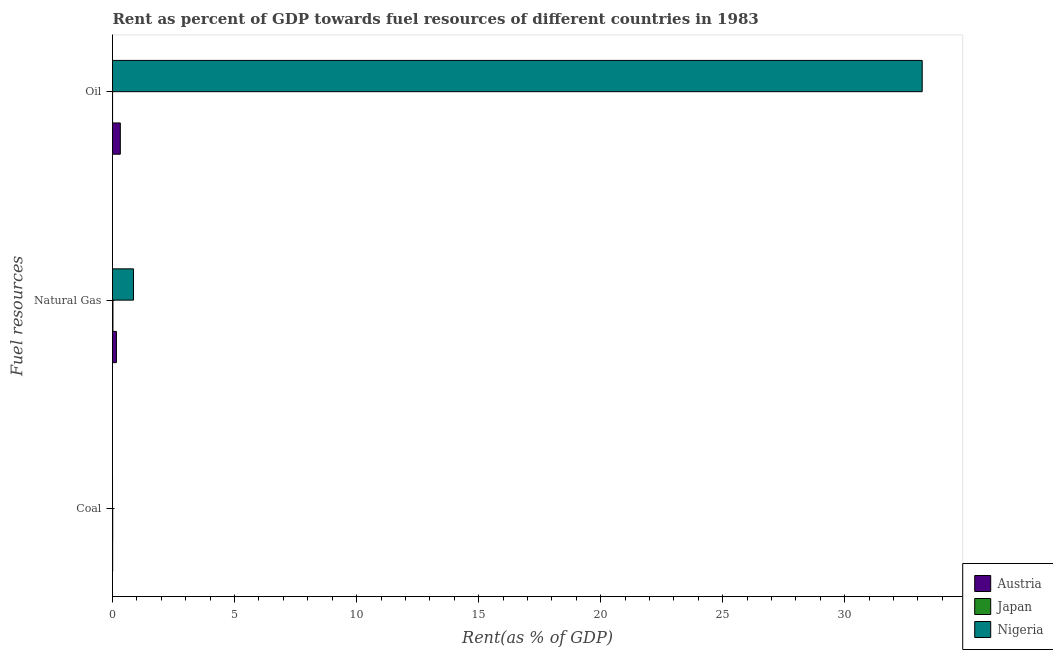How many different coloured bars are there?
Provide a succinct answer. 3. How many groups of bars are there?
Offer a terse response. 3. Are the number of bars per tick equal to the number of legend labels?
Offer a terse response. Yes. How many bars are there on the 1st tick from the top?
Your answer should be very brief. 3. What is the label of the 3rd group of bars from the top?
Keep it short and to the point. Coal. What is the rent towards natural gas in Austria?
Provide a succinct answer. 0.16. Across all countries, what is the maximum rent towards oil?
Your answer should be compact. 33.17. Across all countries, what is the minimum rent towards natural gas?
Provide a succinct answer. 0.02. In which country was the rent towards natural gas maximum?
Provide a succinct answer. Nigeria. In which country was the rent towards oil minimum?
Offer a very short reply. Japan. What is the total rent towards coal in the graph?
Provide a short and direct response. 0.02. What is the difference between the rent towards natural gas in Japan and that in Nigeria?
Your answer should be compact. -0.84. What is the difference between the rent towards natural gas in Nigeria and the rent towards coal in Austria?
Make the answer very short. 0.85. What is the average rent towards coal per country?
Your answer should be compact. 0.01. What is the difference between the rent towards natural gas and rent towards oil in Nigeria?
Provide a short and direct response. -32.31. In how many countries, is the rent towards natural gas greater than 28 %?
Keep it short and to the point. 0. What is the ratio of the rent towards oil in Japan to that in Nigeria?
Offer a terse response. 9.989106129136986e-5. Is the rent towards coal in Nigeria less than that in Japan?
Make the answer very short. Yes. Is the difference between the rent towards coal in Austria and Japan greater than the difference between the rent towards natural gas in Austria and Japan?
Provide a succinct answer. No. What is the difference between the highest and the second highest rent towards natural gas?
Your response must be concise. 0.7. What is the difference between the highest and the lowest rent towards natural gas?
Provide a succinct answer. 0.84. In how many countries, is the rent towards oil greater than the average rent towards oil taken over all countries?
Offer a very short reply. 1. Is the sum of the rent towards oil in Austria and Nigeria greater than the maximum rent towards natural gas across all countries?
Your answer should be compact. Yes. What does the 3rd bar from the top in Coal represents?
Provide a short and direct response. Austria. What does the 1st bar from the bottom in Natural Gas represents?
Your answer should be compact. Austria. Is it the case that in every country, the sum of the rent towards coal and rent towards natural gas is greater than the rent towards oil?
Your answer should be compact. No. Are all the bars in the graph horizontal?
Provide a short and direct response. Yes. How many countries are there in the graph?
Offer a very short reply. 3. Are the values on the major ticks of X-axis written in scientific E-notation?
Your answer should be compact. No. Does the graph contain any zero values?
Your response must be concise. No. Where does the legend appear in the graph?
Ensure brevity in your answer.  Bottom right. How many legend labels are there?
Offer a very short reply. 3. How are the legend labels stacked?
Provide a succinct answer. Vertical. What is the title of the graph?
Keep it short and to the point. Rent as percent of GDP towards fuel resources of different countries in 1983. Does "Malaysia" appear as one of the legend labels in the graph?
Keep it short and to the point. No. What is the label or title of the X-axis?
Offer a terse response. Rent(as % of GDP). What is the label or title of the Y-axis?
Your response must be concise. Fuel resources. What is the Rent(as % of GDP) in Austria in Coal?
Offer a very short reply. 0.01. What is the Rent(as % of GDP) of Japan in Coal?
Your answer should be very brief. 0.01. What is the Rent(as % of GDP) in Nigeria in Coal?
Your response must be concise. 0. What is the Rent(as % of GDP) in Austria in Natural Gas?
Your response must be concise. 0.16. What is the Rent(as % of GDP) in Japan in Natural Gas?
Provide a succinct answer. 0.02. What is the Rent(as % of GDP) in Nigeria in Natural Gas?
Make the answer very short. 0.86. What is the Rent(as % of GDP) of Austria in Oil?
Your answer should be very brief. 0.32. What is the Rent(as % of GDP) in Japan in Oil?
Provide a short and direct response. 0. What is the Rent(as % of GDP) of Nigeria in Oil?
Make the answer very short. 33.17. Across all Fuel resources, what is the maximum Rent(as % of GDP) in Austria?
Give a very brief answer. 0.32. Across all Fuel resources, what is the maximum Rent(as % of GDP) of Japan?
Keep it short and to the point. 0.02. Across all Fuel resources, what is the maximum Rent(as % of GDP) in Nigeria?
Provide a succinct answer. 33.17. Across all Fuel resources, what is the minimum Rent(as % of GDP) of Austria?
Your answer should be compact. 0.01. Across all Fuel resources, what is the minimum Rent(as % of GDP) in Japan?
Offer a terse response. 0. Across all Fuel resources, what is the minimum Rent(as % of GDP) in Nigeria?
Your response must be concise. 0. What is the total Rent(as % of GDP) of Austria in the graph?
Keep it short and to the point. 0.49. What is the total Rent(as % of GDP) of Japan in the graph?
Give a very brief answer. 0.03. What is the total Rent(as % of GDP) of Nigeria in the graph?
Offer a terse response. 34.03. What is the difference between the Rent(as % of GDP) in Austria in Coal and that in Natural Gas?
Provide a short and direct response. -0.15. What is the difference between the Rent(as % of GDP) in Japan in Coal and that in Natural Gas?
Offer a very short reply. -0.01. What is the difference between the Rent(as % of GDP) of Nigeria in Coal and that in Natural Gas?
Offer a terse response. -0.86. What is the difference between the Rent(as % of GDP) of Austria in Coal and that in Oil?
Ensure brevity in your answer.  -0.31. What is the difference between the Rent(as % of GDP) in Japan in Coal and that in Oil?
Keep it short and to the point. 0.01. What is the difference between the Rent(as % of GDP) of Nigeria in Coal and that in Oil?
Your answer should be compact. -33.17. What is the difference between the Rent(as % of GDP) of Austria in Natural Gas and that in Oil?
Provide a short and direct response. -0.16. What is the difference between the Rent(as % of GDP) in Japan in Natural Gas and that in Oil?
Your answer should be very brief. 0.01. What is the difference between the Rent(as % of GDP) of Nigeria in Natural Gas and that in Oil?
Your answer should be compact. -32.31. What is the difference between the Rent(as % of GDP) in Austria in Coal and the Rent(as % of GDP) in Japan in Natural Gas?
Provide a short and direct response. -0.01. What is the difference between the Rent(as % of GDP) of Austria in Coal and the Rent(as % of GDP) of Nigeria in Natural Gas?
Your response must be concise. -0.85. What is the difference between the Rent(as % of GDP) of Japan in Coal and the Rent(as % of GDP) of Nigeria in Natural Gas?
Offer a terse response. -0.85. What is the difference between the Rent(as % of GDP) of Austria in Coal and the Rent(as % of GDP) of Japan in Oil?
Offer a very short reply. 0. What is the difference between the Rent(as % of GDP) of Austria in Coal and the Rent(as % of GDP) of Nigeria in Oil?
Provide a short and direct response. -33.17. What is the difference between the Rent(as % of GDP) of Japan in Coal and the Rent(as % of GDP) of Nigeria in Oil?
Keep it short and to the point. -33.16. What is the difference between the Rent(as % of GDP) in Austria in Natural Gas and the Rent(as % of GDP) in Japan in Oil?
Your answer should be very brief. 0.16. What is the difference between the Rent(as % of GDP) of Austria in Natural Gas and the Rent(as % of GDP) of Nigeria in Oil?
Offer a very short reply. -33.01. What is the difference between the Rent(as % of GDP) in Japan in Natural Gas and the Rent(as % of GDP) in Nigeria in Oil?
Your answer should be compact. -33.16. What is the average Rent(as % of GDP) in Austria per Fuel resources?
Keep it short and to the point. 0.16. What is the average Rent(as % of GDP) of Japan per Fuel resources?
Give a very brief answer. 0.01. What is the average Rent(as % of GDP) in Nigeria per Fuel resources?
Make the answer very short. 11.34. What is the difference between the Rent(as % of GDP) in Austria and Rent(as % of GDP) in Japan in Coal?
Provide a short and direct response. -0. What is the difference between the Rent(as % of GDP) of Austria and Rent(as % of GDP) of Nigeria in Coal?
Give a very brief answer. 0.01. What is the difference between the Rent(as % of GDP) of Japan and Rent(as % of GDP) of Nigeria in Coal?
Give a very brief answer. 0.01. What is the difference between the Rent(as % of GDP) in Austria and Rent(as % of GDP) in Japan in Natural Gas?
Provide a succinct answer. 0.14. What is the difference between the Rent(as % of GDP) in Austria and Rent(as % of GDP) in Nigeria in Natural Gas?
Keep it short and to the point. -0.7. What is the difference between the Rent(as % of GDP) in Japan and Rent(as % of GDP) in Nigeria in Natural Gas?
Provide a succinct answer. -0.84. What is the difference between the Rent(as % of GDP) of Austria and Rent(as % of GDP) of Japan in Oil?
Give a very brief answer. 0.32. What is the difference between the Rent(as % of GDP) of Austria and Rent(as % of GDP) of Nigeria in Oil?
Make the answer very short. -32.85. What is the difference between the Rent(as % of GDP) in Japan and Rent(as % of GDP) in Nigeria in Oil?
Provide a short and direct response. -33.17. What is the ratio of the Rent(as % of GDP) in Austria in Coal to that in Natural Gas?
Offer a very short reply. 0.04. What is the ratio of the Rent(as % of GDP) in Japan in Coal to that in Natural Gas?
Offer a very short reply. 0.53. What is the ratio of the Rent(as % of GDP) in Nigeria in Coal to that in Natural Gas?
Your answer should be very brief. 0. What is the ratio of the Rent(as % of GDP) of Austria in Coal to that in Oil?
Your answer should be very brief. 0.02. What is the ratio of the Rent(as % of GDP) in Japan in Coal to that in Oil?
Your answer should be very brief. 2.89. What is the ratio of the Rent(as % of GDP) in Nigeria in Coal to that in Oil?
Offer a very short reply. 0. What is the ratio of the Rent(as % of GDP) in Austria in Natural Gas to that in Oil?
Your response must be concise. 0.5. What is the ratio of the Rent(as % of GDP) in Japan in Natural Gas to that in Oil?
Offer a terse response. 5.48. What is the ratio of the Rent(as % of GDP) in Nigeria in Natural Gas to that in Oil?
Offer a terse response. 0.03. What is the difference between the highest and the second highest Rent(as % of GDP) of Austria?
Keep it short and to the point. 0.16. What is the difference between the highest and the second highest Rent(as % of GDP) of Japan?
Your response must be concise. 0.01. What is the difference between the highest and the second highest Rent(as % of GDP) in Nigeria?
Provide a succinct answer. 32.31. What is the difference between the highest and the lowest Rent(as % of GDP) in Austria?
Your answer should be very brief. 0.31. What is the difference between the highest and the lowest Rent(as % of GDP) in Japan?
Your answer should be very brief. 0.01. What is the difference between the highest and the lowest Rent(as % of GDP) in Nigeria?
Your answer should be compact. 33.17. 